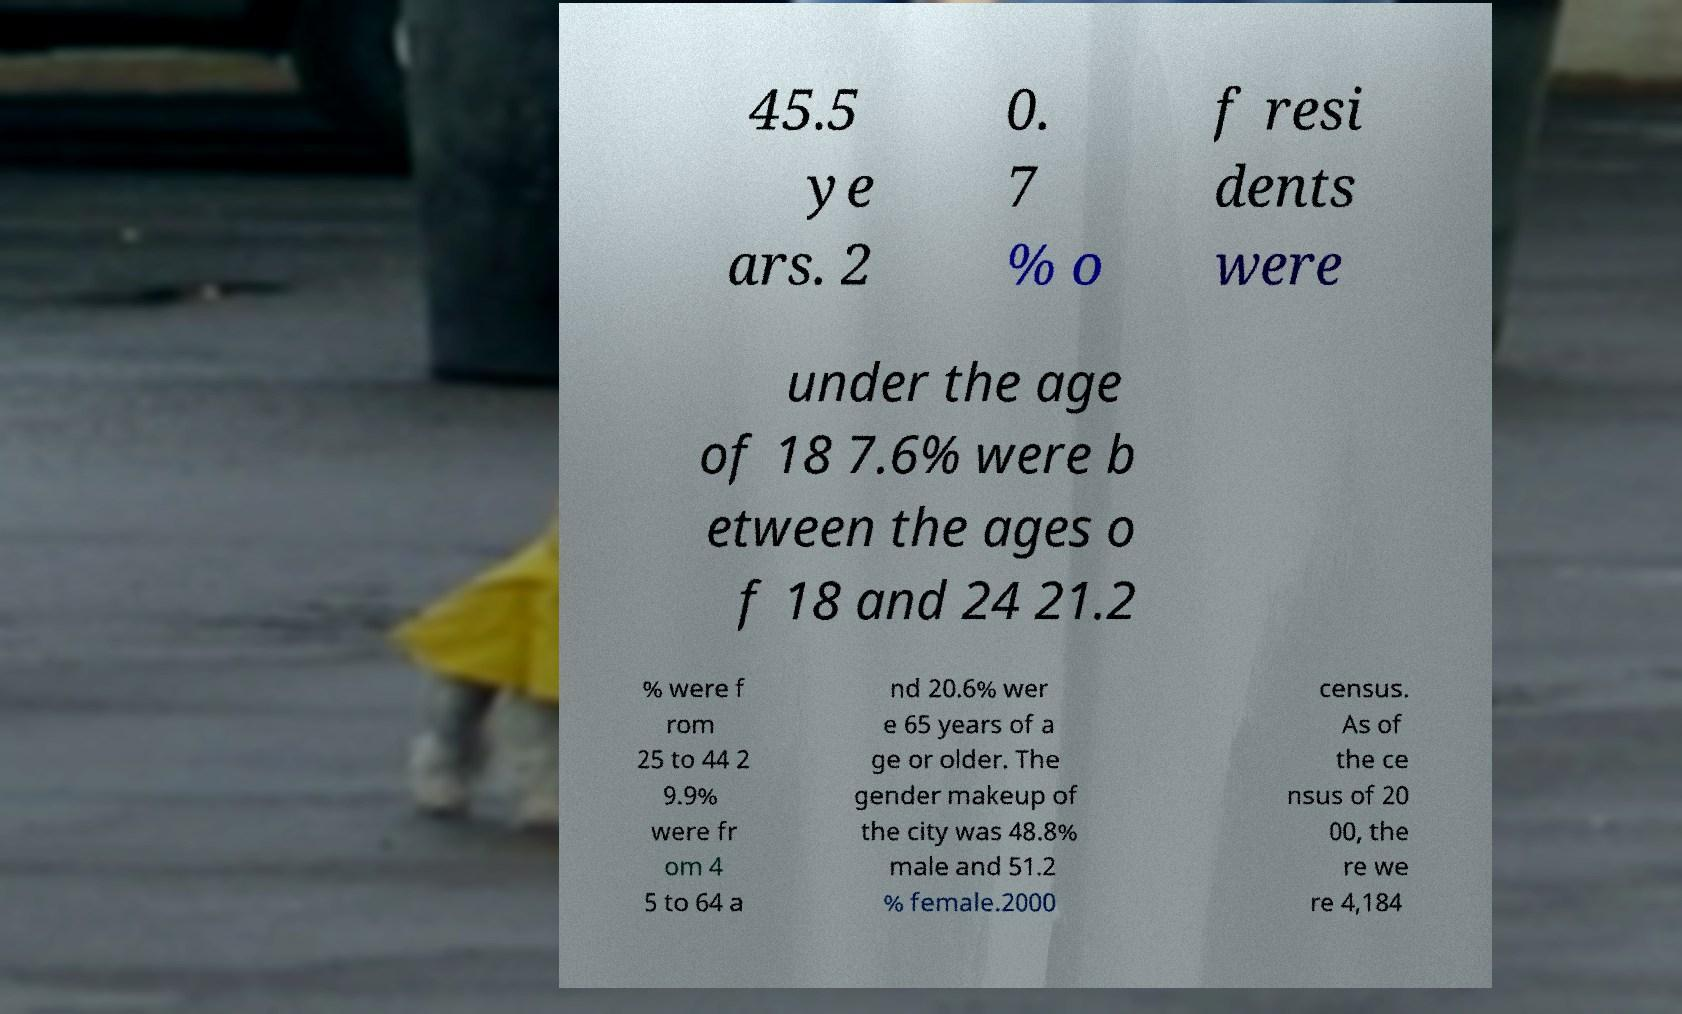Please identify and transcribe the text found in this image. 45.5 ye ars. 2 0. 7 % o f resi dents were under the age of 18 7.6% were b etween the ages o f 18 and 24 21.2 % were f rom 25 to 44 2 9.9% were fr om 4 5 to 64 a nd 20.6% wer e 65 years of a ge or older. The gender makeup of the city was 48.8% male and 51.2 % female.2000 census. As of the ce nsus of 20 00, the re we re 4,184 